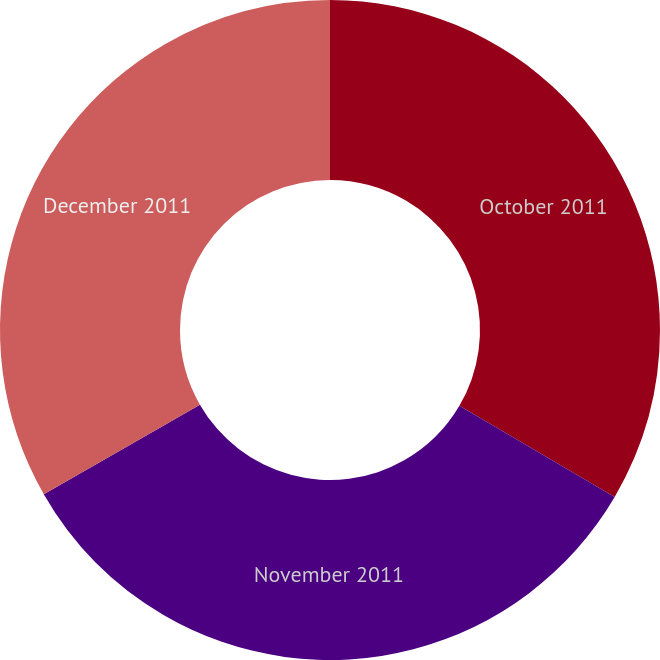Convert chart. <chart><loc_0><loc_0><loc_500><loc_500><pie_chart><fcel>October 2011<fcel>November 2011<fcel>December 2011<nl><fcel>33.44%<fcel>33.27%<fcel>33.29%<nl></chart> 